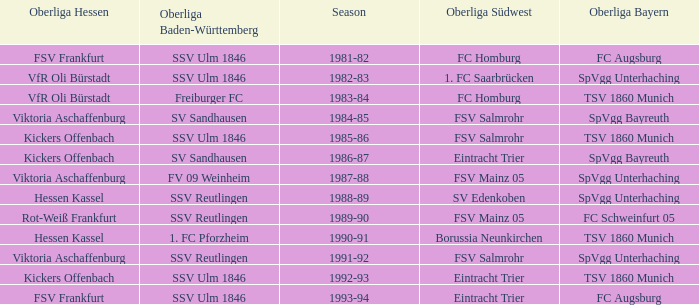Which Oberliga Bayern has a Season of 1981-82? FC Augsburg. 